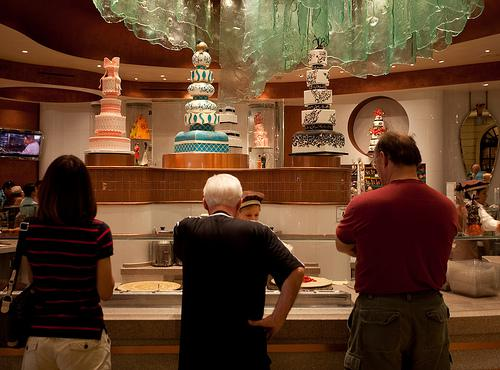Question: how many people are waiting in this picture?
Choices:
A. Two.
B. Three.
C. Four.
D. Five.
Answer with the letter. Answer: B Question: what is the woman making in this picture?
Choices:
A. Cakes.
B. Pastries.
C. Brownies.
D. Pies.
Answer with the letter. Answer: B Question: who is this woman?
Choices:
A. The cashier.
B. The pastry chef.
C. The bank teller.
D. A customer.
Answer with the letter. Answer: B Question: what do you buy here?
Choices:
A. Canoes and rowboats.
B. Dog food and leashes.
C. Coffee and tea.
D. Pastries and cakes.
Answer with the letter. Answer: D Question: what are those three items in the middle of the picture?
Choices:
A. Brownies.
B. Cookies.
C. Pies.
D. Cakes.
Answer with the letter. Answer: D 